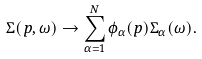<formula> <loc_0><loc_0><loc_500><loc_500>\Sigma ( p , \omega ) \rightarrow \sum _ { \alpha = 1 } ^ { N } \phi _ { \alpha } ( p ) \Sigma _ { \alpha } ( \omega ) .</formula> 